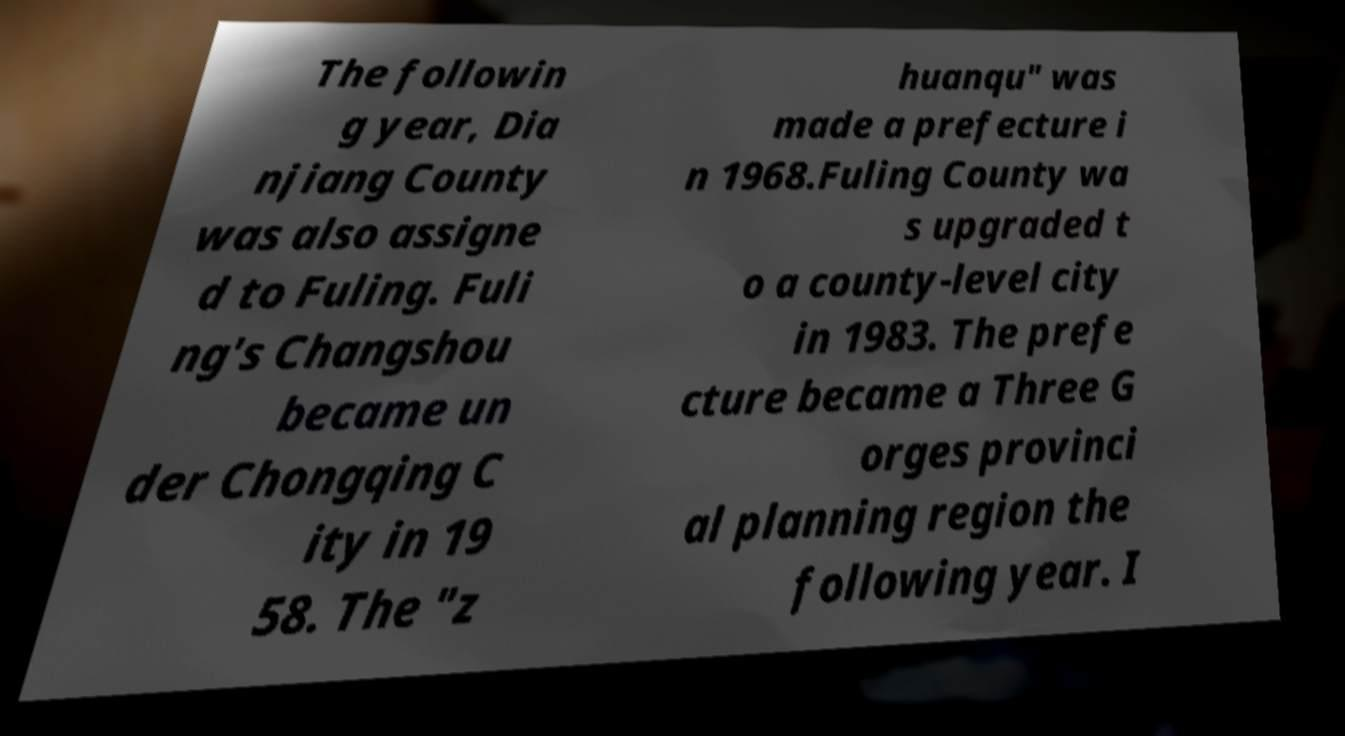Could you assist in decoding the text presented in this image and type it out clearly? The followin g year, Dia njiang County was also assigne d to Fuling. Fuli ng's Changshou became un der Chongqing C ity in 19 58. The "z huanqu" was made a prefecture i n 1968.Fuling County wa s upgraded t o a county-level city in 1983. The prefe cture became a Three G orges provinci al planning region the following year. I 